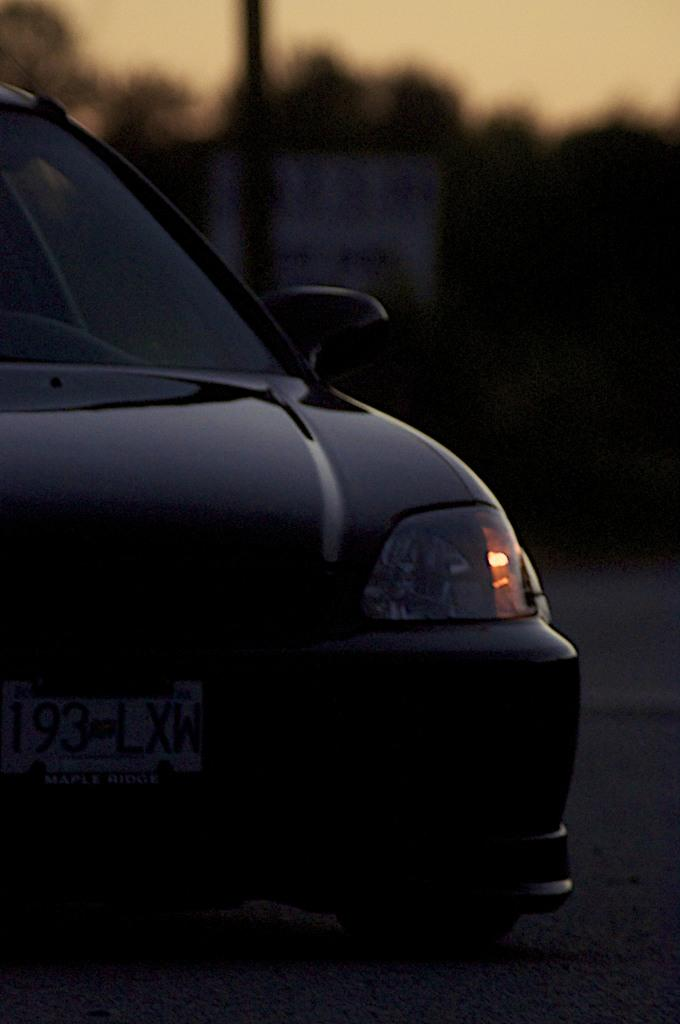What color is the car in the image? The car in the image is black. Where is the car located in the image? The car is on the road in the image. What identifies the car in the image? There is a number plate on the car. What can be seen in the background of the image? There is a board, a pole, trees, and the sky visible in the background of the image. Can you tell me how many birds are sitting on the car in the image? There are no birds present on the car in the image. What type of guide is holding the pole in the background of the image? There is no guide holding the pole in the background of the image; it is a stationary object. 